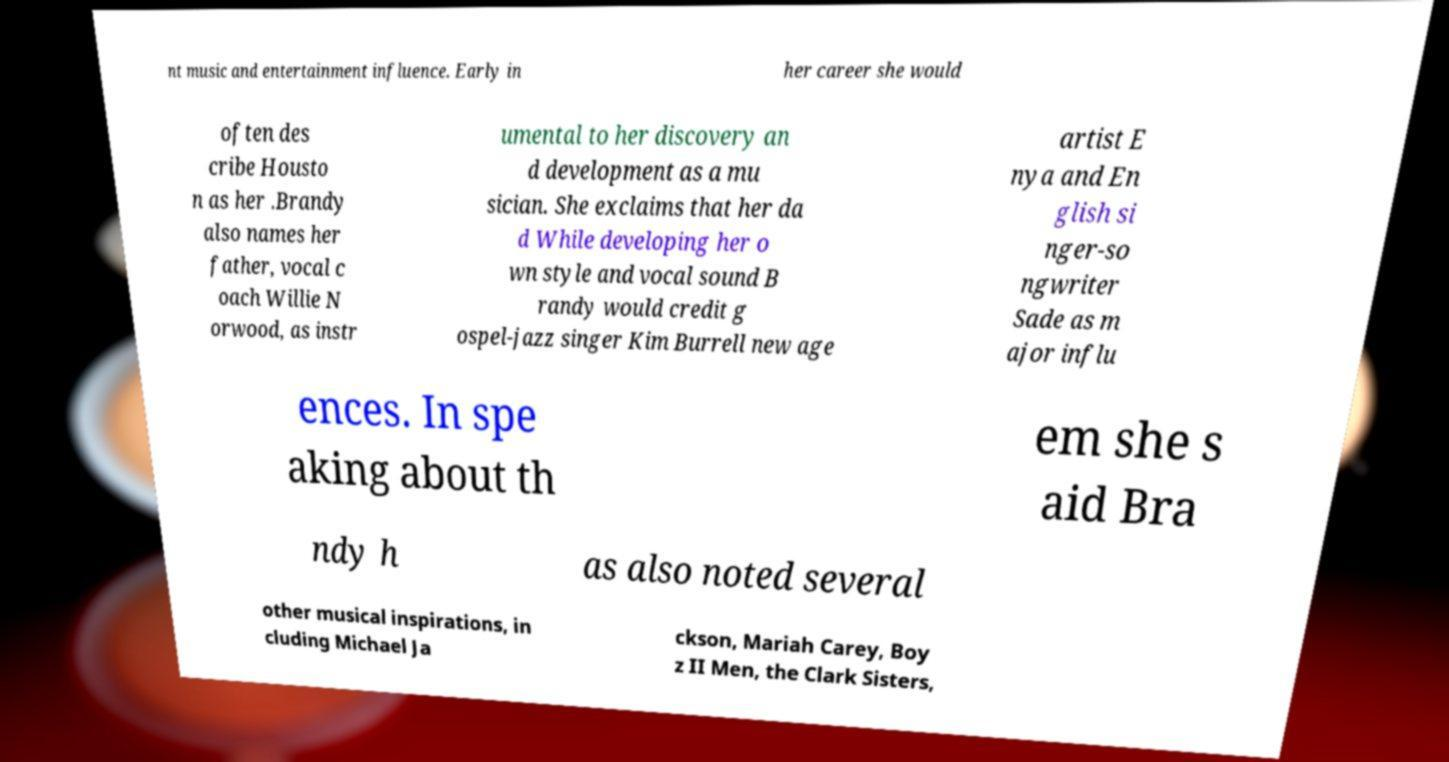Can you accurately transcribe the text from the provided image for me? nt music and entertainment influence. Early in her career she would often des cribe Housto n as her .Brandy also names her father, vocal c oach Willie N orwood, as instr umental to her discovery an d development as a mu sician. She exclaims that her da d While developing her o wn style and vocal sound B randy would credit g ospel-jazz singer Kim Burrell new age artist E nya and En glish si nger-so ngwriter Sade as m ajor influ ences. In spe aking about th em she s aid Bra ndy h as also noted several other musical inspirations, in cluding Michael Ja ckson, Mariah Carey, Boy z II Men, the Clark Sisters, 